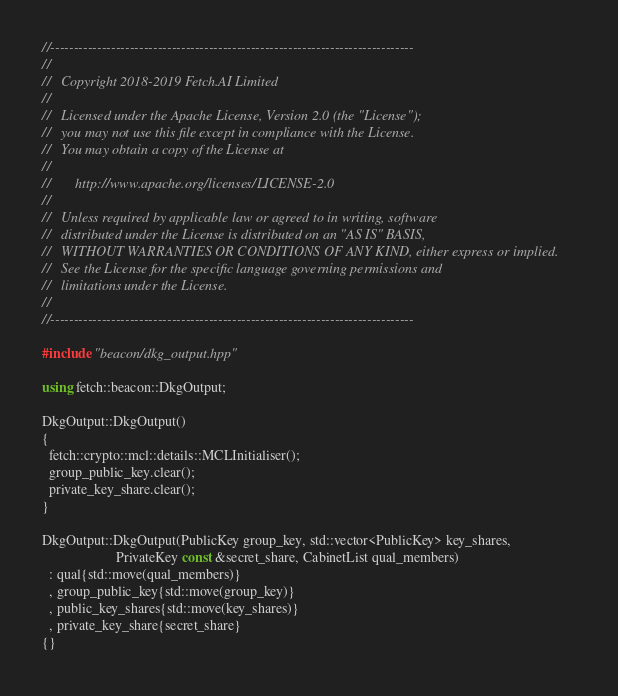Convert code to text. <code><loc_0><loc_0><loc_500><loc_500><_C++_>//------------------------------------------------------------------------------
//
//   Copyright 2018-2019 Fetch.AI Limited
//
//   Licensed under the Apache License, Version 2.0 (the "License");
//   you may not use this file except in compliance with the License.
//   You may obtain a copy of the License at
//
//       http://www.apache.org/licenses/LICENSE-2.0
//
//   Unless required by applicable law or agreed to in writing, software
//   distributed under the License is distributed on an "AS IS" BASIS,
//   WITHOUT WARRANTIES OR CONDITIONS OF ANY KIND, either express or implied.
//   See the License for the specific language governing permissions and
//   limitations under the License.
//
//------------------------------------------------------------------------------

#include "beacon/dkg_output.hpp"

using fetch::beacon::DkgOutput;

DkgOutput::DkgOutput()
{
  fetch::crypto::mcl::details::MCLInitialiser();
  group_public_key.clear();
  private_key_share.clear();
}

DkgOutput::DkgOutput(PublicKey group_key, std::vector<PublicKey> key_shares,
                     PrivateKey const &secret_share, CabinetList qual_members)
  : qual{std::move(qual_members)}
  , group_public_key{std::move(group_key)}
  , public_key_shares{std::move(key_shares)}
  , private_key_share{secret_share}
{}
</code> 